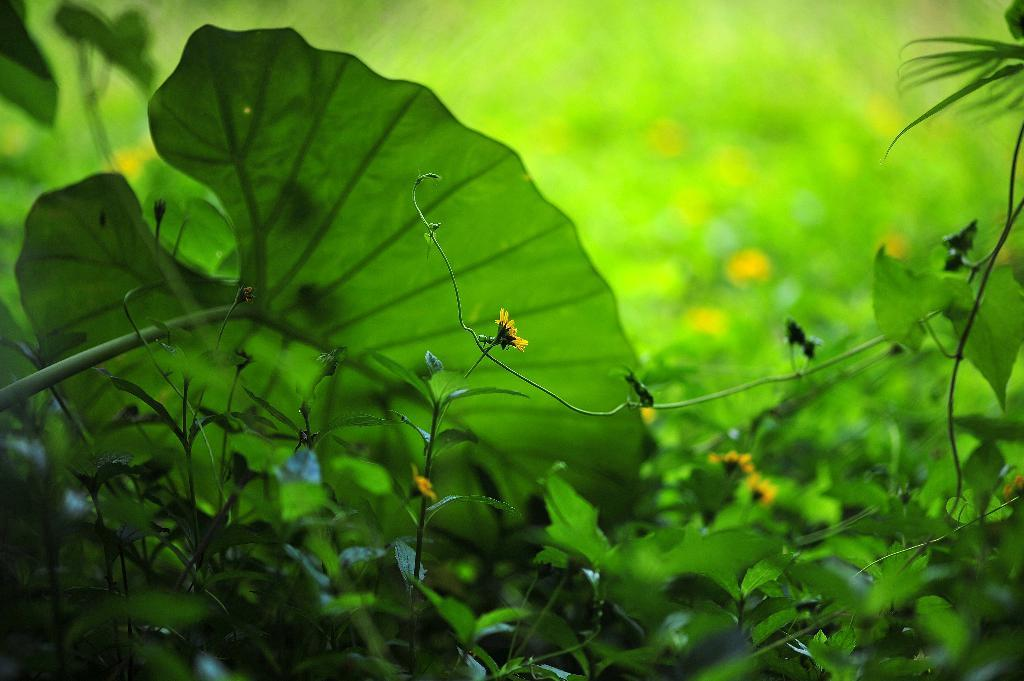What type of plants are visible in the image? There are green plants in the image. Are there any flowers on the plants? Yes, some of the plants have yellow flowers. What type of locket can be seen hanging from the plants in the image? There is no locket present in the image; it only features green plants with yellow flowers. 